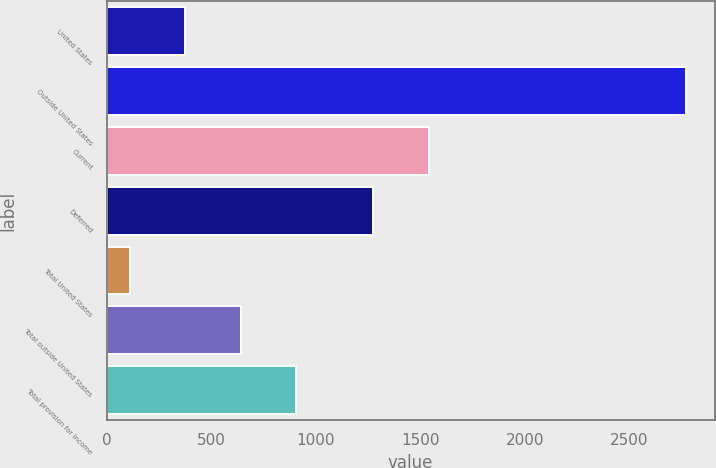<chart> <loc_0><loc_0><loc_500><loc_500><bar_chart><fcel>United States<fcel>Outside United States<fcel>Current<fcel>Deferred<fcel>Total United States<fcel>Total outside United States<fcel>Total provision for income<nl><fcel>376<fcel>2770<fcel>1540<fcel>1274<fcel>110<fcel>642<fcel>908<nl></chart> 